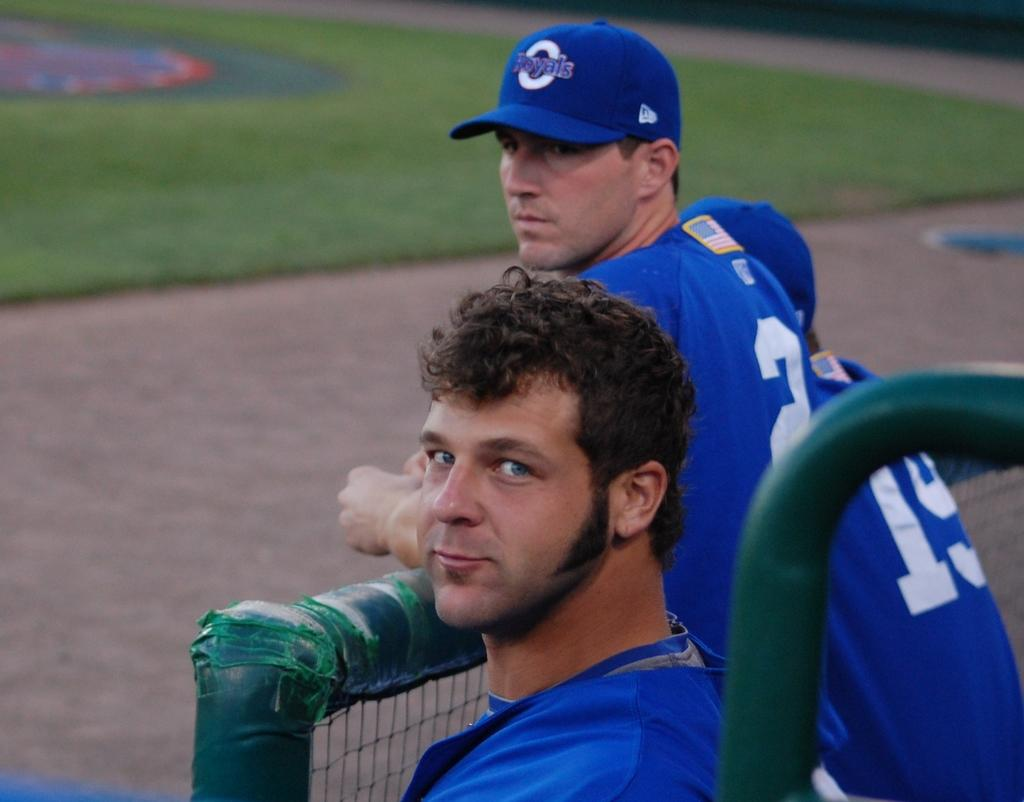How many people are in the image? There are three persons in the image. Can you describe the clothing of one of the individuals? One man is wearing a blue cap. What type of structure can be seen in the image? There is fencing in the image. What type of natural environment is visible in the image? Grass is visible in the image. What type of instrument is the mailbox playing in the image? There is no mailbox or instrument present in the image. What color is the floor in the image? There is no floor visible in the image; it is an outdoor scene with grass and fencing. 